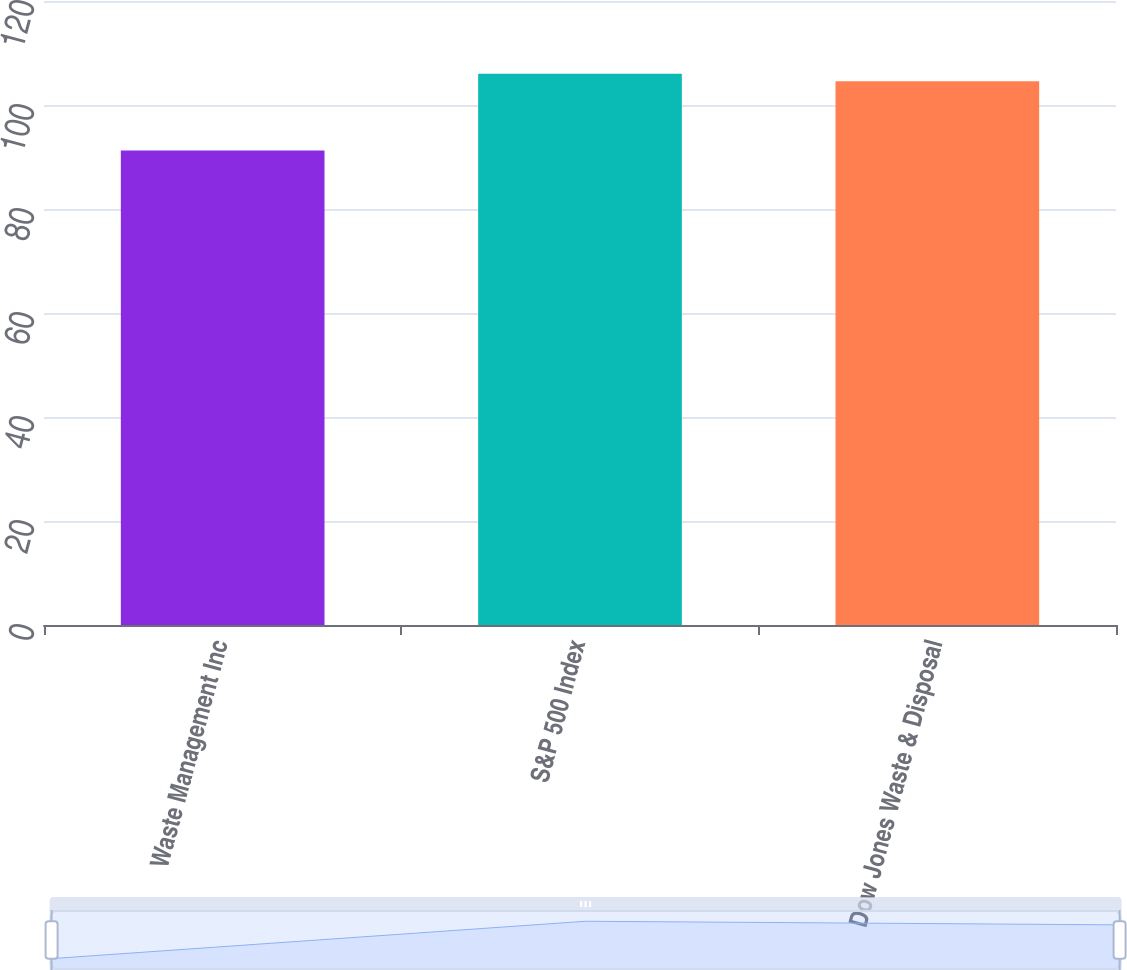Convert chart. <chart><loc_0><loc_0><loc_500><loc_500><bar_chart><fcel>Waste Management Inc<fcel>S&P 500 Index<fcel>Dow Jones Waste & Disposal<nl><fcel>91.23<fcel>106<fcel>104.57<nl></chart> 